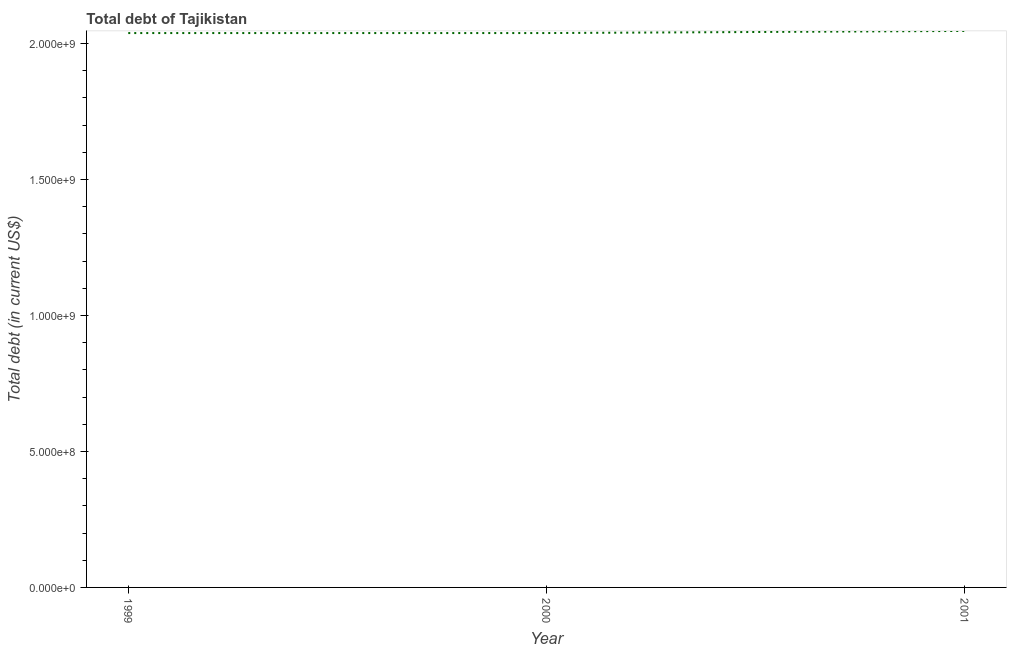What is the total debt in 1999?
Your answer should be compact. 2.04e+09. Across all years, what is the maximum total debt?
Provide a short and direct response. 2.05e+09. Across all years, what is the minimum total debt?
Your answer should be compact. 2.04e+09. What is the sum of the total debt?
Provide a short and direct response. 6.12e+09. What is the average total debt per year?
Your answer should be very brief. 2.04e+09. What is the median total debt?
Your answer should be very brief. 2.04e+09. Do a majority of the years between 2001 and 2000 (inclusive) have total debt greater than 1700000000 US$?
Offer a very short reply. No. What is the ratio of the total debt in 2000 to that in 2001?
Your answer should be compact. 1. What is the difference between the highest and the second highest total debt?
Your answer should be very brief. 7.82e+06. Is the sum of the total debt in 2000 and 2001 greater than the maximum total debt across all years?
Provide a succinct answer. Yes. What is the difference between the highest and the lowest total debt?
Keep it short and to the point. 7.82e+06. In how many years, is the total debt greater than the average total debt taken over all years?
Make the answer very short. 1. Does the total debt monotonically increase over the years?
Offer a very short reply. No. What is the difference between two consecutive major ticks on the Y-axis?
Make the answer very short. 5.00e+08. Are the values on the major ticks of Y-axis written in scientific E-notation?
Make the answer very short. Yes. What is the title of the graph?
Offer a very short reply. Total debt of Tajikistan. What is the label or title of the Y-axis?
Your answer should be compact. Total debt (in current US$). What is the Total debt (in current US$) in 1999?
Offer a terse response. 2.04e+09. What is the Total debt (in current US$) in 2000?
Your answer should be very brief. 2.04e+09. What is the Total debt (in current US$) of 2001?
Your answer should be compact. 2.05e+09. What is the difference between the Total debt (in current US$) in 1999 and 2000?
Your answer should be compact. 0. What is the difference between the Total debt (in current US$) in 1999 and 2001?
Give a very brief answer. -7.82e+06. What is the difference between the Total debt (in current US$) in 2000 and 2001?
Provide a short and direct response. -7.82e+06. What is the ratio of the Total debt (in current US$) in 1999 to that in 2000?
Keep it short and to the point. 1. 